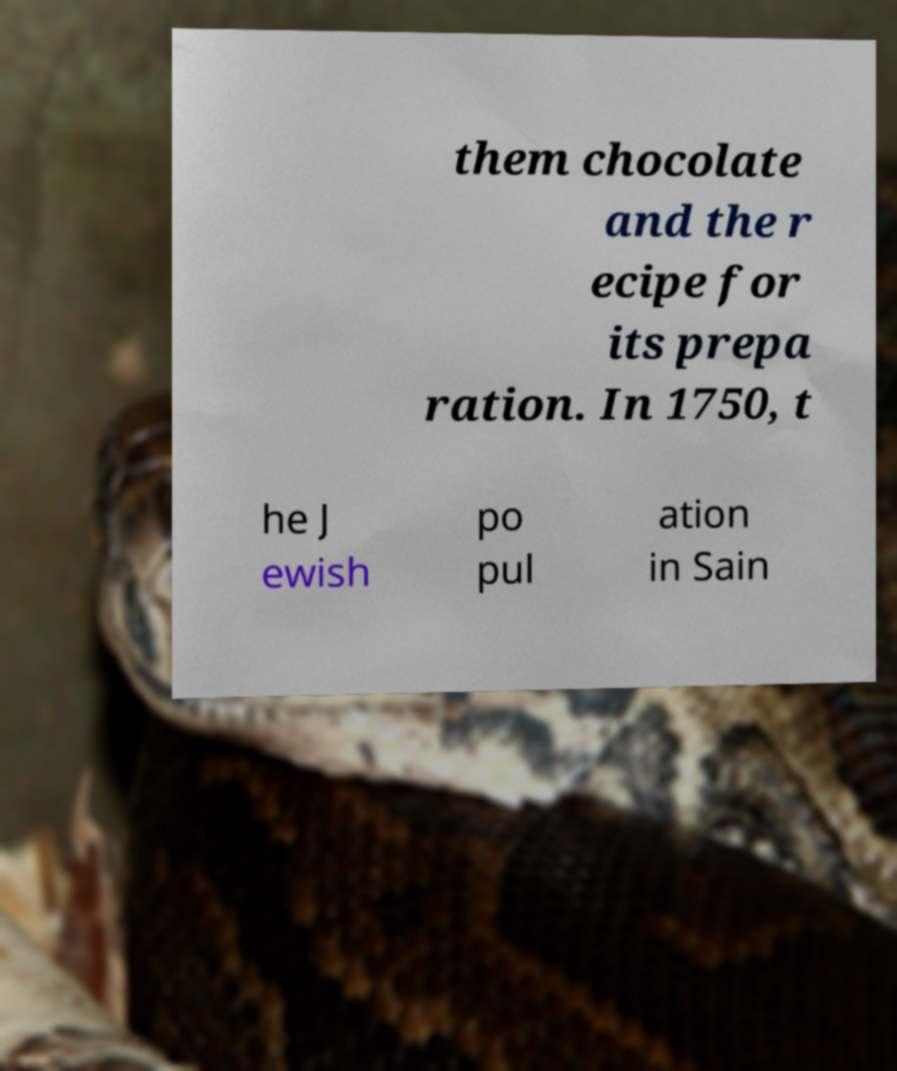Could you assist in decoding the text presented in this image and type it out clearly? them chocolate and the r ecipe for its prepa ration. In 1750, t he J ewish po pul ation in Sain 